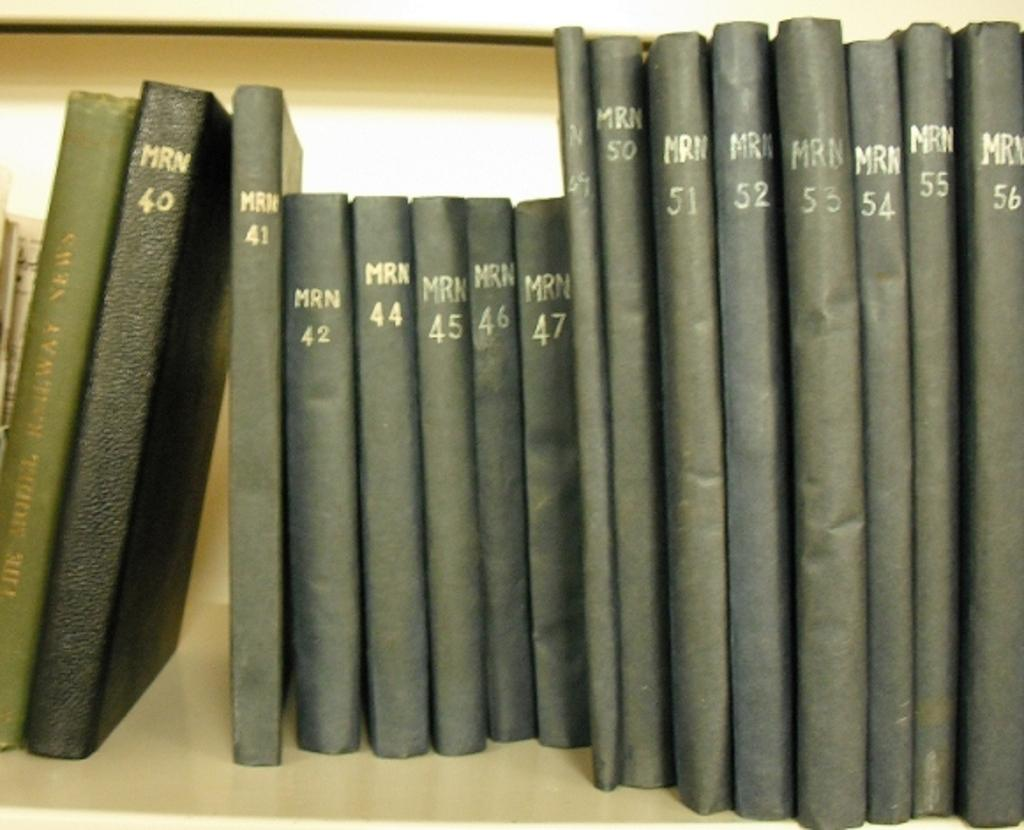What objects can be seen in the image? There are books in the image. Where are the books located? The books are on a bookshelf. What is your aunt doing in the tub in the image? There is no aunt or tub present in the image; it only features books on a bookshelf. 